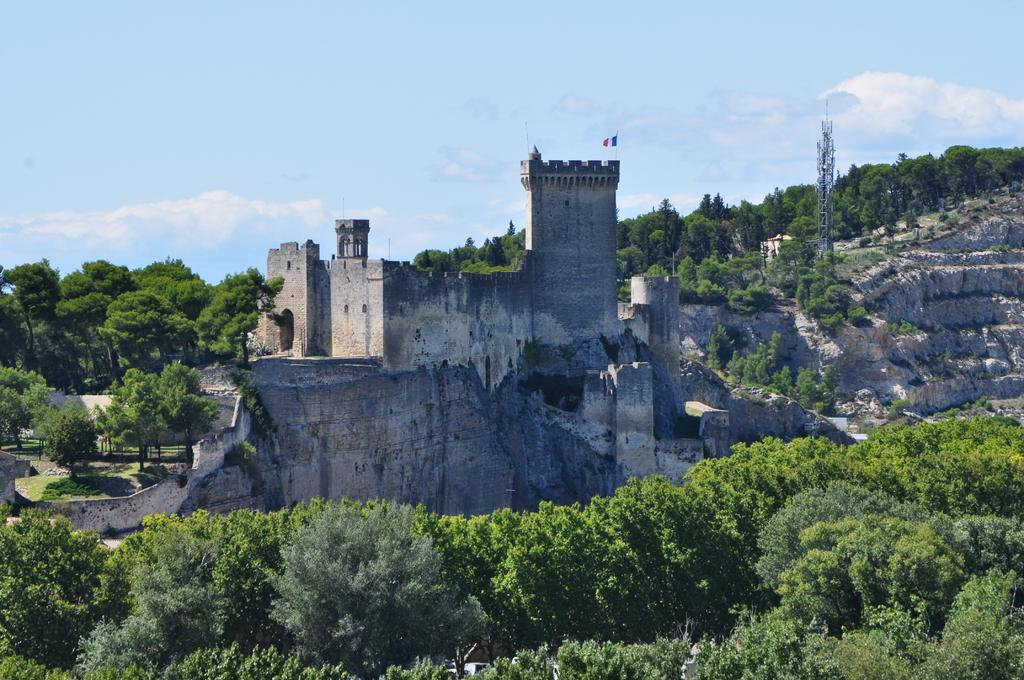What type of structure is in the picture? There is a fort in the picture. What is attached to the flag in the picture? There is a flag with a pole in the picture. What type of natural vegetation is in the picture? There are trees in the picture. What modern structure can be seen in the picture? There is a cell tower in the picture. What is visible in the background of the picture? The sky is visible in the background of the picture. How much money is being exchanged between the guide and the tourists in the picture? There is no guide or tourists present in the picture, and therefore no money exchange can be observed. 